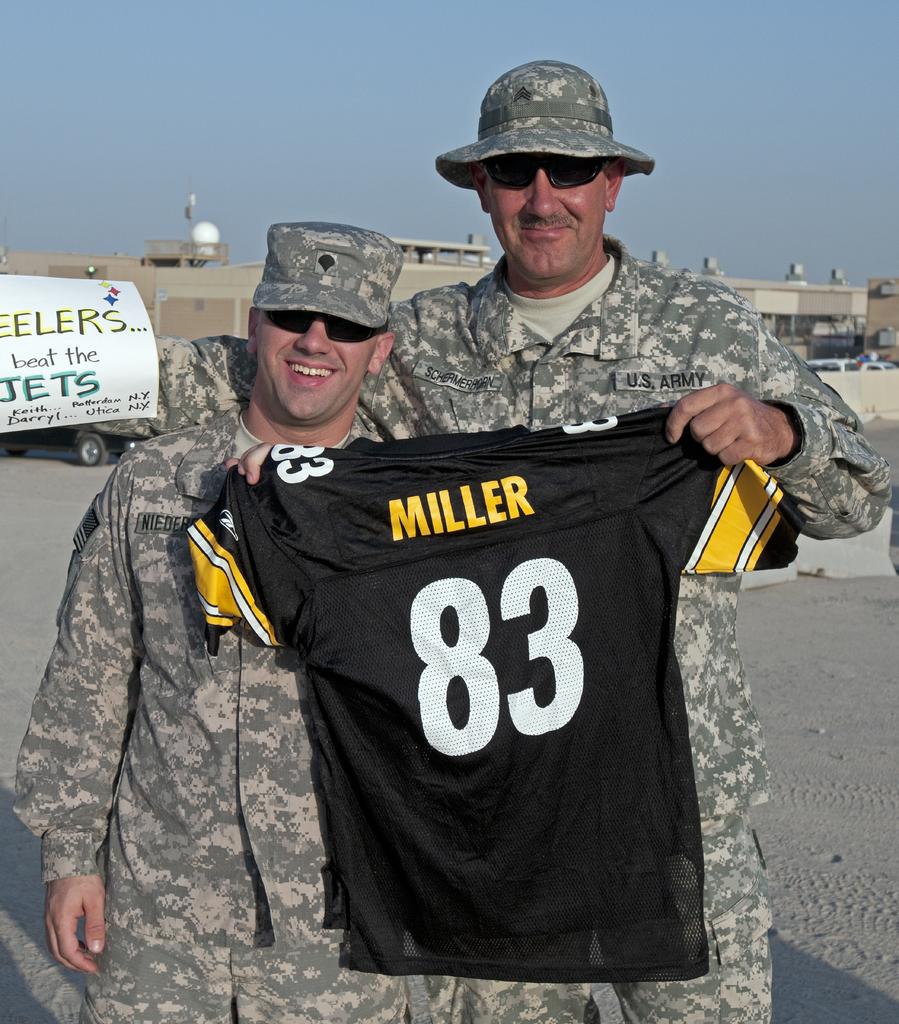What is miller's jersey number?
Provide a short and direct response. 83. What sports team is written on the white sign in the rear?
Give a very brief answer. Jets. 